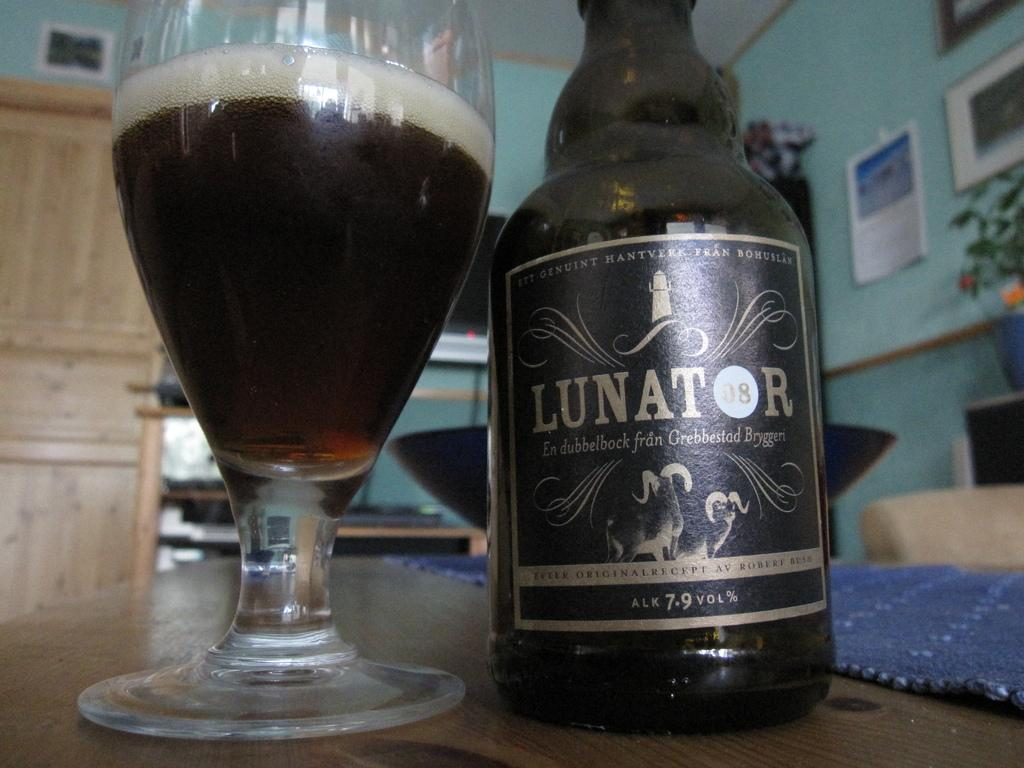<image>
Describe the image concisely. the word lunator that is on a bottle 